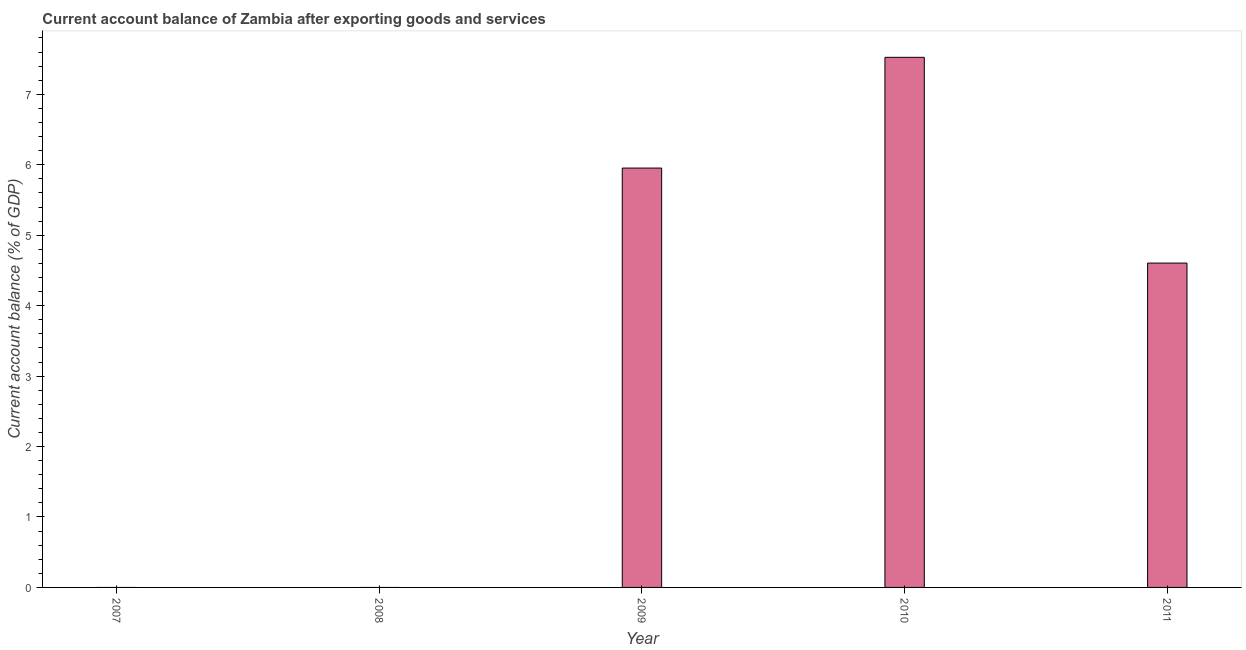Does the graph contain any zero values?
Your response must be concise. Yes. Does the graph contain grids?
Your response must be concise. No. What is the title of the graph?
Provide a succinct answer. Current account balance of Zambia after exporting goods and services. What is the label or title of the Y-axis?
Keep it short and to the point. Current account balance (% of GDP). What is the current account balance in 2011?
Keep it short and to the point. 4.6. Across all years, what is the maximum current account balance?
Make the answer very short. 7.53. Across all years, what is the minimum current account balance?
Your response must be concise. 0. In which year was the current account balance maximum?
Ensure brevity in your answer.  2010. What is the sum of the current account balance?
Offer a terse response. 18.08. What is the difference between the current account balance in 2009 and 2010?
Provide a short and direct response. -1.57. What is the average current account balance per year?
Provide a succinct answer. 3.62. What is the median current account balance?
Keep it short and to the point. 4.6. What is the ratio of the current account balance in 2009 to that in 2011?
Offer a very short reply. 1.29. Is the difference between the current account balance in 2010 and 2011 greater than the difference between any two years?
Your answer should be very brief. No. What is the difference between the highest and the second highest current account balance?
Your answer should be very brief. 1.57. What is the difference between the highest and the lowest current account balance?
Give a very brief answer. 7.53. In how many years, is the current account balance greater than the average current account balance taken over all years?
Your answer should be very brief. 3. How many bars are there?
Your answer should be compact. 3. Are all the bars in the graph horizontal?
Your response must be concise. No. What is the difference between two consecutive major ticks on the Y-axis?
Your response must be concise. 1. What is the Current account balance (% of GDP) of 2007?
Your answer should be very brief. 0. What is the Current account balance (% of GDP) of 2009?
Offer a very short reply. 5.95. What is the Current account balance (% of GDP) of 2010?
Keep it short and to the point. 7.53. What is the Current account balance (% of GDP) in 2011?
Provide a short and direct response. 4.6. What is the difference between the Current account balance (% of GDP) in 2009 and 2010?
Give a very brief answer. -1.57. What is the difference between the Current account balance (% of GDP) in 2009 and 2011?
Your response must be concise. 1.35. What is the difference between the Current account balance (% of GDP) in 2010 and 2011?
Make the answer very short. 2.92. What is the ratio of the Current account balance (% of GDP) in 2009 to that in 2010?
Your response must be concise. 0.79. What is the ratio of the Current account balance (% of GDP) in 2009 to that in 2011?
Your answer should be very brief. 1.29. What is the ratio of the Current account balance (% of GDP) in 2010 to that in 2011?
Provide a short and direct response. 1.63. 